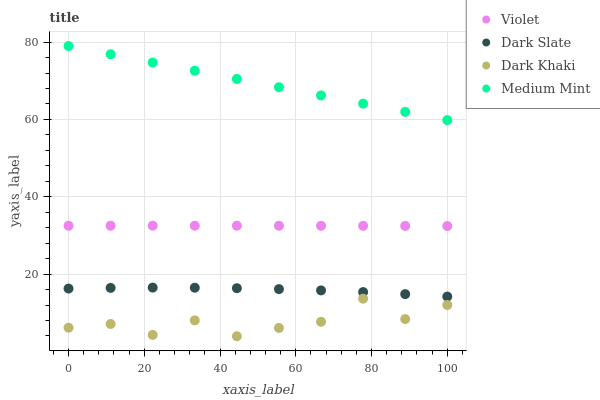Does Dark Khaki have the minimum area under the curve?
Answer yes or no. Yes. Does Medium Mint have the maximum area under the curve?
Answer yes or no. Yes. Does Dark Slate have the minimum area under the curve?
Answer yes or no. No. Does Dark Slate have the maximum area under the curve?
Answer yes or no. No. Is Medium Mint the smoothest?
Answer yes or no. Yes. Is Dark Khaki the roughest?
Answer yes or no. Yes. Is Dark Slate the smoothest?
Answer yes or no. No. Is Dark Slate the roughest?
Answer yes or no. No. Does Dark Khaki have the lowest value?
Answer yes or no. Yes. Does Dark Slate have the lowest value?
Answer yes or no. No. Does Medium Mint have the highest value?
Answer yes or no. Yes. Does Dark Slate have the highest value?
Answer yes or no. No. Is Dark Slate less than Medium Mint?
Answer yes or no. Yes. Is Medium Mint greater than Violet?
Answer yes or no. Yes. Does Dark Slate intersect Medium Mint?
Answer yes or no. No. 